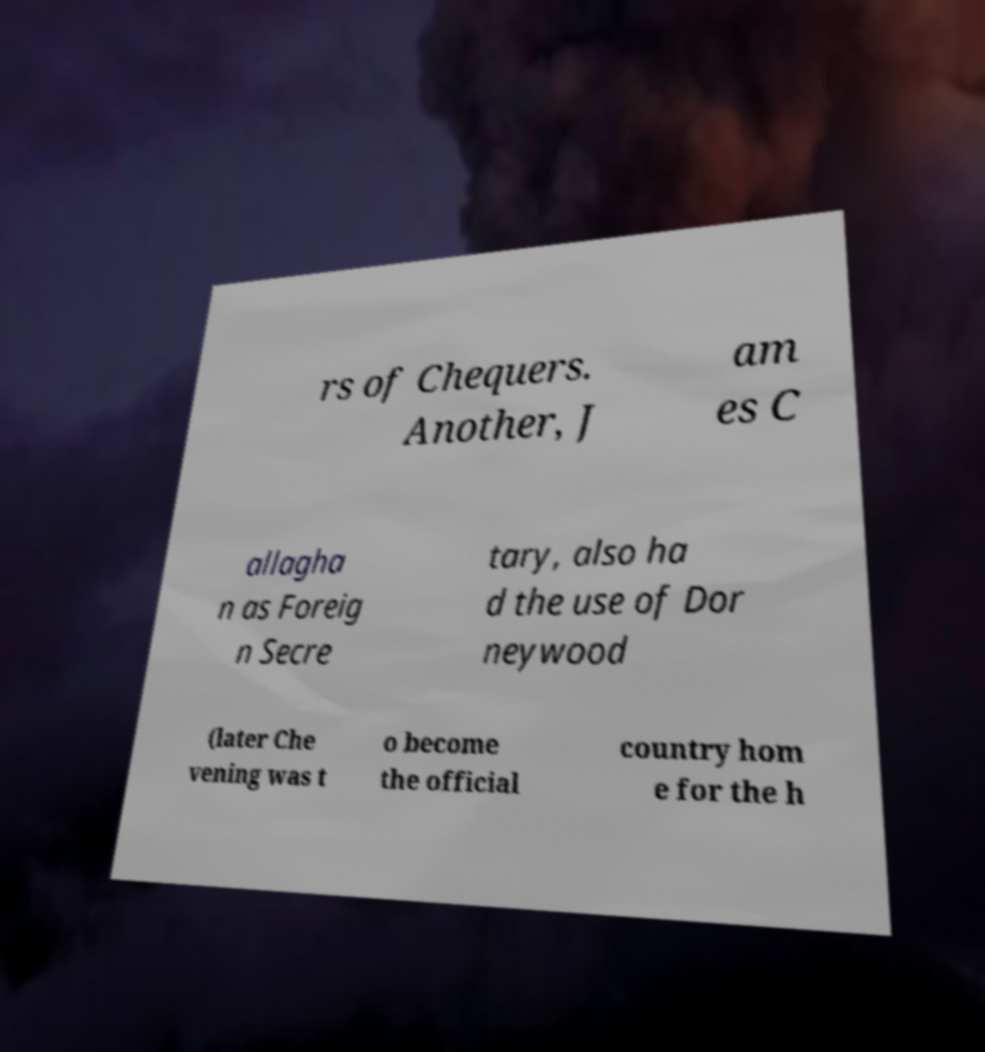Can you read and provide the text displayed in the image?This photo seems to have some interesting text. Can you extract and type it out for me? rs of Chequers. Another, J am es C allagha n as Foreig n Secre tary, also ha d the use of Dor neywood (later Che vening was t o become the official country hom e for the h 